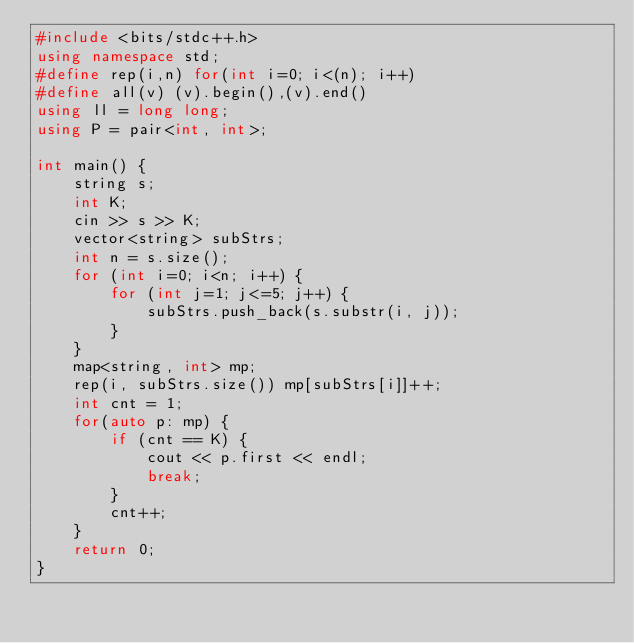<code> <loc_0><loc_0><loc_500><loc_500><_C++_>#include <bits/stdc++.h>
using namespace std;
#define rep(i,n) for(int i=0; i<(n); i++)
#define all(v) (v).begin(),(v).end()
using ll = long long;
using P = pair<int, int>;
 
int main() {
    string s;
    int K;
    cin >> s >> K;
    vector<string> subStrs;
    int n = s.size();
    for (int i=0; i<n; i++) {
        for (int j=1; j<=5; j++) {
            subStrs.push_back(s.substr(i, j));
        }
    }
    map<string, int> mp;
    rep(i, subStrs.size()) mp[subStrs[i]]++;
    int cnt = 1;
    for(auto p: mp) {
        if (cnt == K) {
            cout << p.first << endl;
            break;
        }
        cnt++;
    }
    return 0;
}</code> 